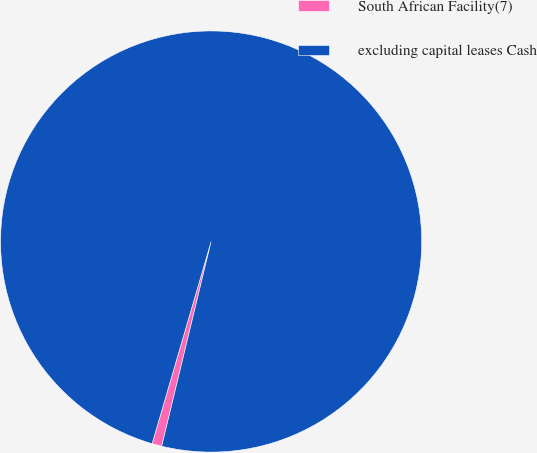Convert chart to OTSL. <chart><loc_0><loc_0><loc_500><loc_500><pie_chart><fcel>South African Facility(7)<fcel>excluding capital leases Cash<nl><fcel>0.75%<fcel>99.25%<nl></chart> 